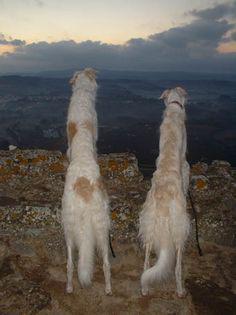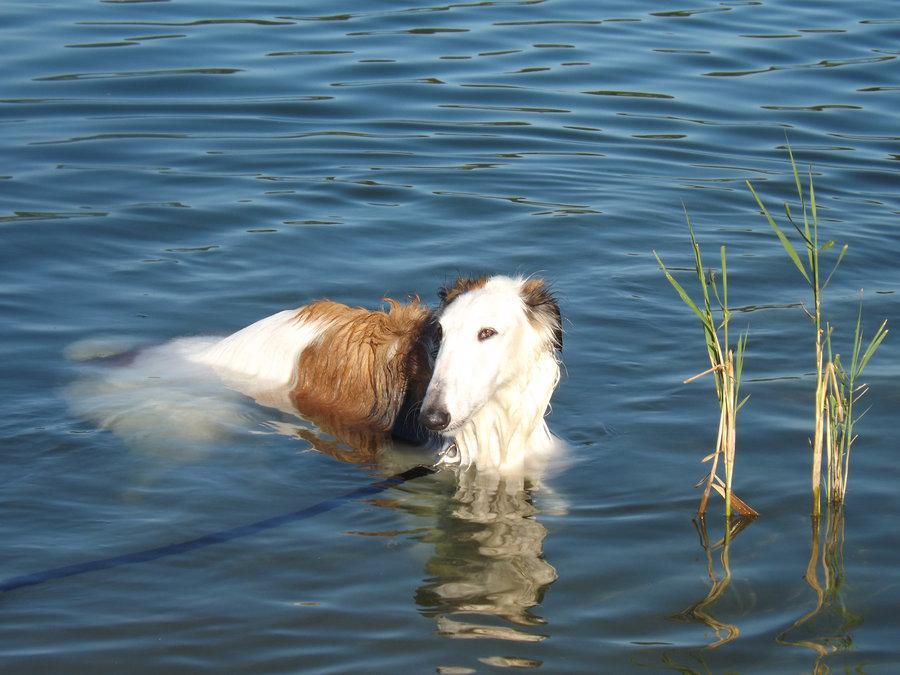The first image is the image on the left, the second image is the image on the right. Evaluate the accuracy of this statement regarding the images: "In the image on the left a dog is leaping into the air by the water.". Is it true? Answer yes or no. No. The first image is the image on the left, the second image is the image on the right. Analyze the images presented: Is the assertion "A single dog is in the water in the image on the right." valid? Answer yes or no. Yes. 